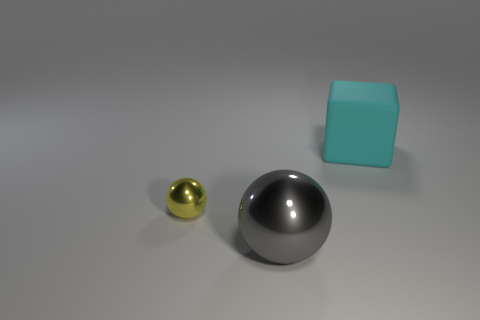What is the size of the sphere that is in front of the metallic object to the left of the gray metallic object?
Make the answer very short. Large. There is a thing that is both behind the gray metallic thing and on the right side of the small yellow metal thing; what is its material?
Your answer should be compact. Rubber. The large ball is what color?
Make the answer very short. Gray. Are there any other things that have the same material as the gray thing?
Ensure brevity in your answer.  Yes. There is a object that is in front of the yellow metal sphere; what shape is it?
Keep it short and to the point. Sphere. There is a big thing right of the shiny object that is on the right side of the small thing; are there any yellow shiny balls in front of it?
Your response must be concise. Yes. Are there any other things that are the same shape as the small object?
Your response must be concise. Yes. Are any big green shiny blocks visible?
Offer a terse response. No. Do the ball that is in front of the small metal object and the tiny thing behind the big gray shiny sphere have the same material?
Ensure brevity in your answer.  Yes. There is a thing that is to the right of the ball right of the metal ball that is behind the big metal object; what size is it?
Your answer should be compact. Large. 